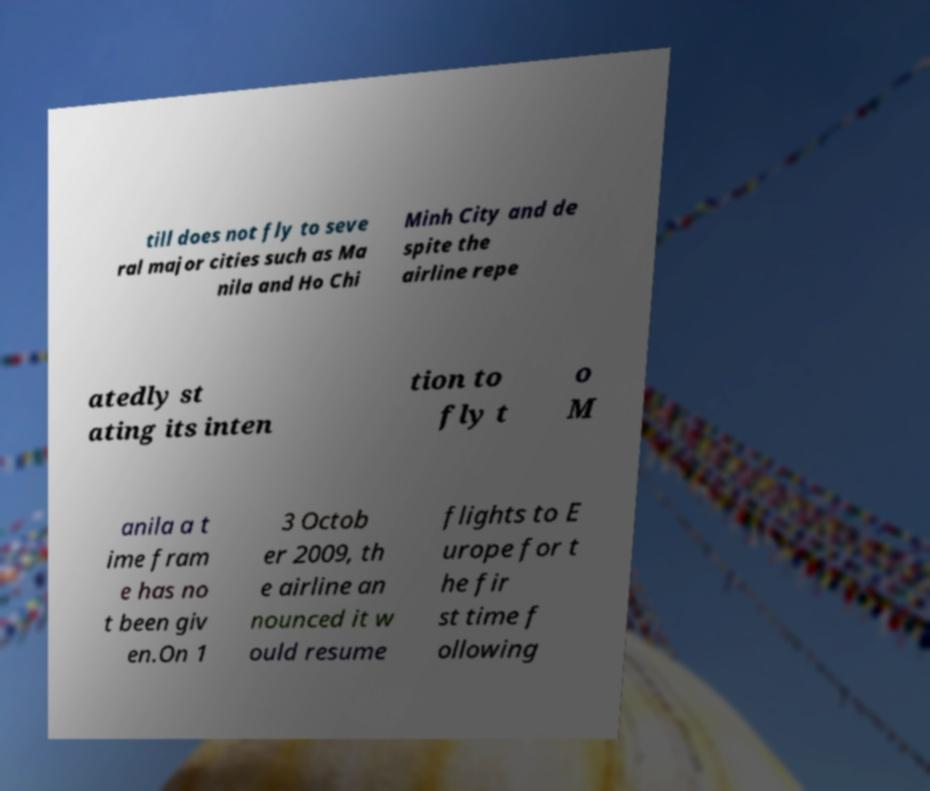Please read and relay the text visible in this image. What does it say? till does not fly to seve ral major cities such as Ma nila and Ho Chi Minh City and de spite the airline repe atedly st ating its inten tion to fly t o M anila a t ime fram e has no t been giv en.On 1 3 Octob er 2009, th e airline an nounced it w ould resume flights to E urope for t he fir st time f ollowing 